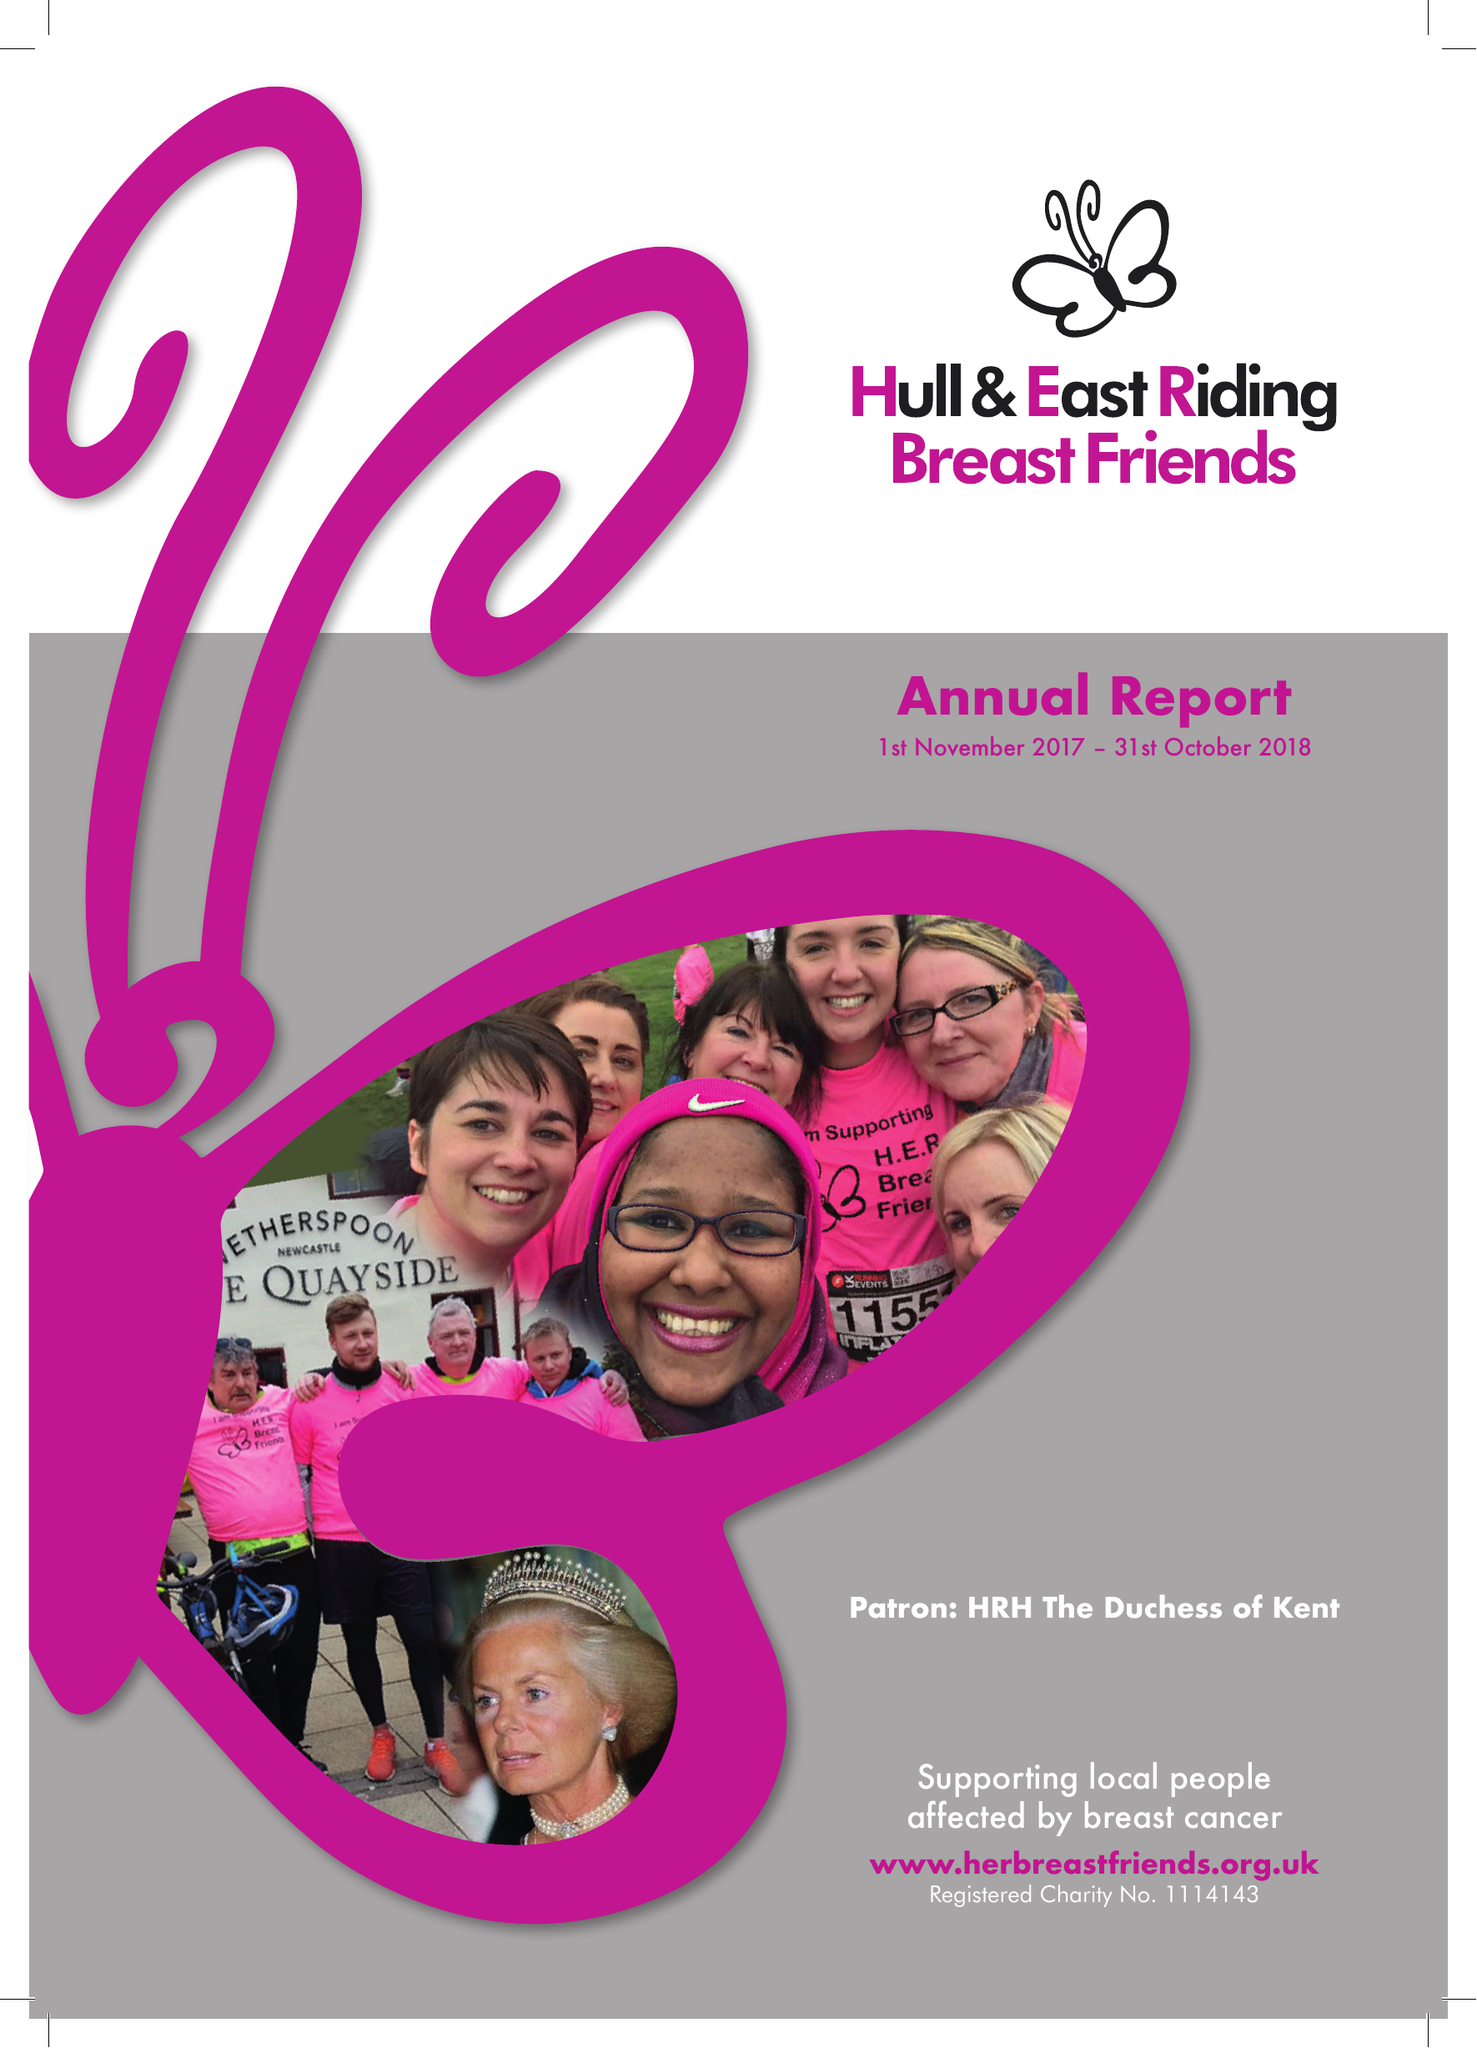What is the value for the address__post_town?
Answer the question using a single word or phrase. HULL 